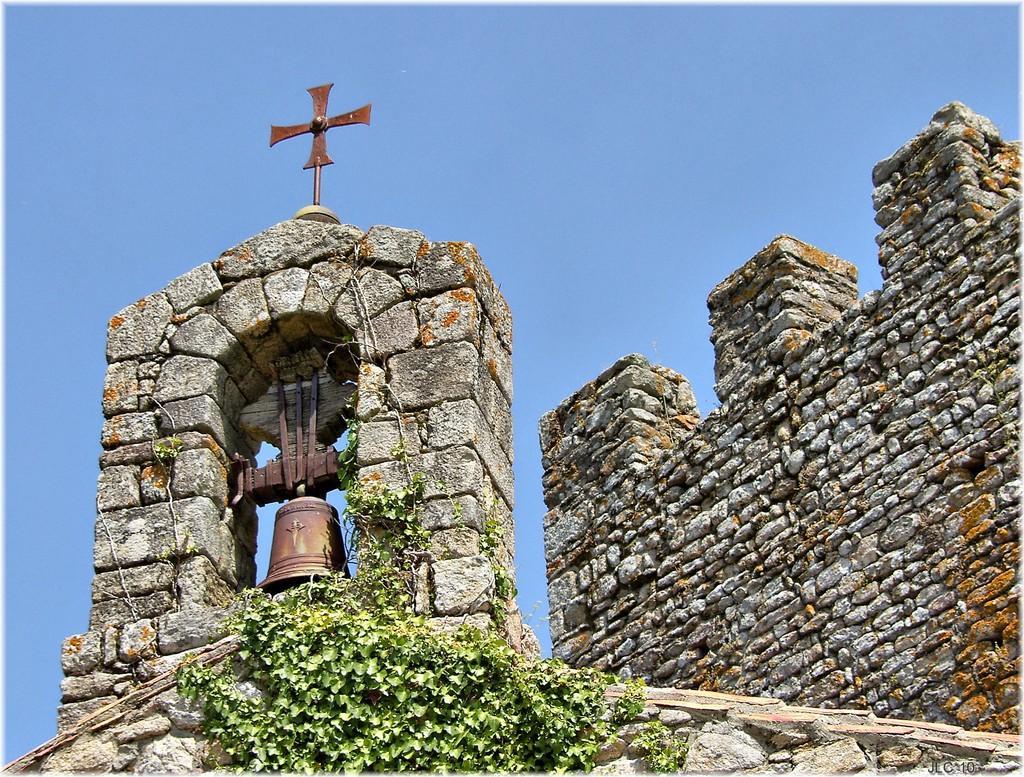Please provide a concise description of this image. In this image there is a stone wall having few creepers on it. A ball is attached to the wall. On the wall there is an object. Background there is sky. 